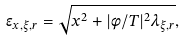<formula> <loc_0><loc_0><loc_500><loc_500>\epsilon _ { x , \xi , r } = \sqrt { x ^ { 2 } + | \phi / T | ^ { 2 } \lambda _ { \xi , r } } ,</formula> 